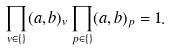<formula> <loc_0><loc_0><loc_500><loc_500>\prod _ { v \in \{ \} } ( a , b ) _ { v } \prod _ { p \in \{ \} } ( a , b ) _ { p } = 1 .</formula> 